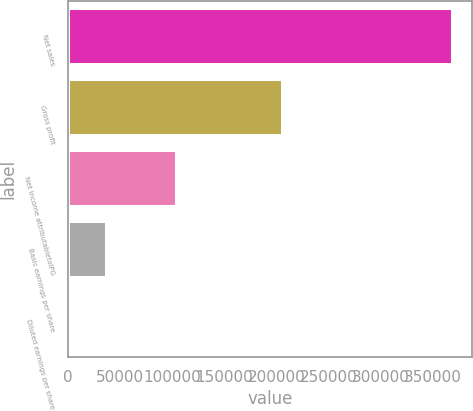<chart> <loc_0><loc_0><loc_500><loc_500><bar_chart><fcel>Net sales<fcel>Gross profit<fcel>Net income attributabletoIPG<fcel>Basic earnings per share<fcel>Diluted earnings per share<nl><fcel>369373<fcel>206296<fcel>104116<fcel>36939<fcel>1.91<nl></chart> 